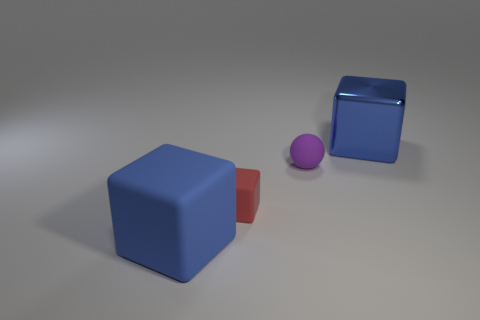Is the color of the big shiny thing the same as the big block in front of the tiny red thing?
Your answer should be very brief. Yes. What color is the metal cube that is on the right side of the large block on the left side of the big block to the right of the small purple rubber object?
Make the answer very short. Blue. What is the color of the other tiny thing that is the same shape as the shiny object?
Give a very brief answer. Red. Is the number of tiny purple matte things that are right of the large blue shiny block the same as the number of small yellow matte objects?
Give a very brief answer. Yes. What number of cubes are either purple rubber objects or big blue rubber things?
Your response must be concise. 1. There is a small cube that is the same material as the ball; what color is it?
Offer a very short reply. Red. Are the small red block and the blue thing that is to the left of the small matte cube made of the same material?
Your answer should be compact. Yes. What number of objects are cubes or cyan metal cylinders?
Your answer should be compact. 3. What material is the big cube that is the same color as the large metallic object?
Your answer should be compact. Rubber. Are there any other matte objects of the same shape as the tiny red object?
Offer a terse response. Yes. 